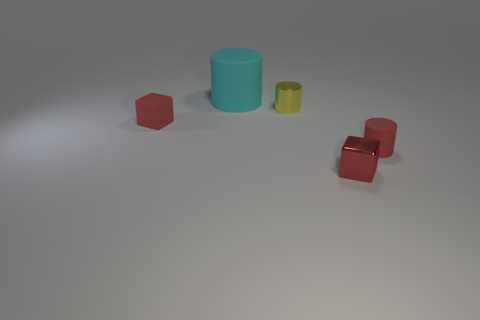Add 4 big gray shiny spheres. How many objects exist? 9 Subtract all cubes. How many objects are left? 3 Add 1 cubes. How many cubes are left? 3 Add 3 tiny red matte things. How many tiny red matte things exist? 5 Subtract 0 green cylinders. How many objects are left? 5 Subtract all purple shiny objects. Subtract all small metallic cylinders. How many objects are left? 4 